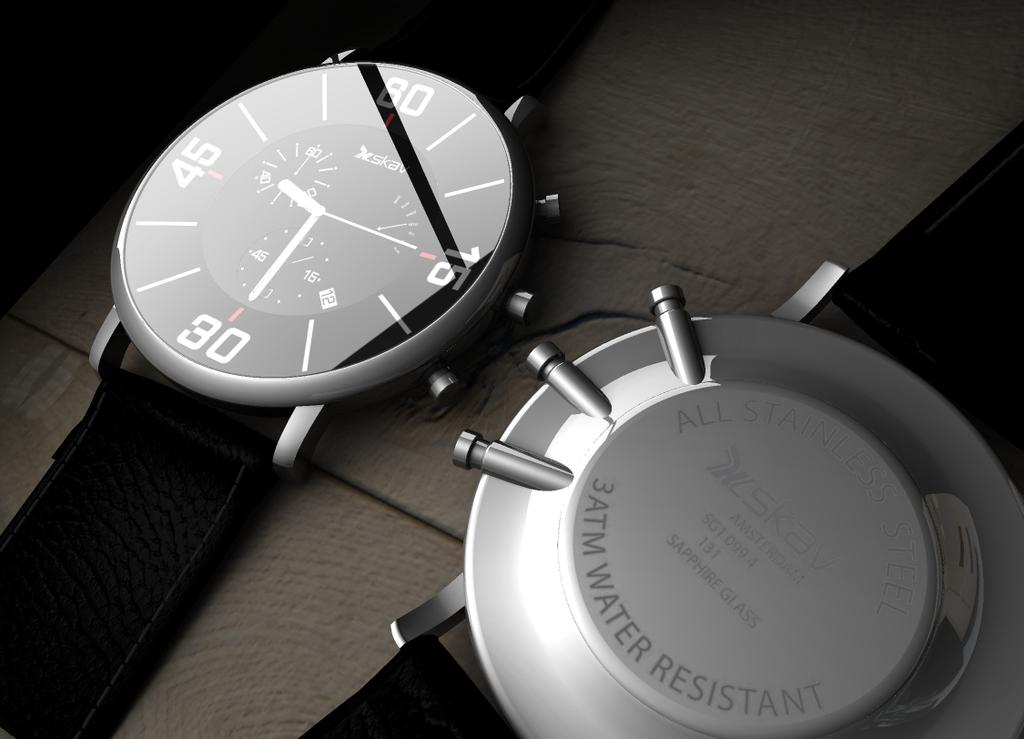<image>
Relay a brief, clear account of the picture shown. Two watches sit side by side on shows the back side and read 3ATM water resistant. 